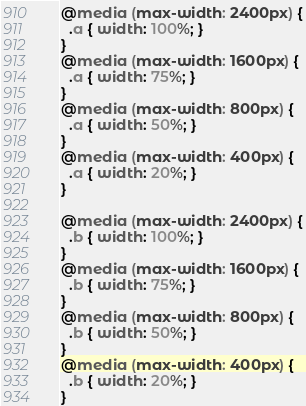<code> <loc_0><loc_0><loc_500><loc_500><_CSS_>@media (max-width: 2400px) {
  .a { width: 100%; }
}
@media (max-width: 1600px) {
  .a { width: 75%; }
}
@media (max-width: 800px) {
  .a { width: 50%; }
}
@media (max-width: 400px) {
  .a { width: 20%; }
}

@media (max-width: 2400px) {
  .b { width: 100%; }
}
@media (max-width: 1600px) {
  .b { width: 75%; }
}
@media (max-width: 800px) {
  .b { width: 50%; }
}
@media (max-width: 400px) {
  .b { width: 20%; }
}
</code> 